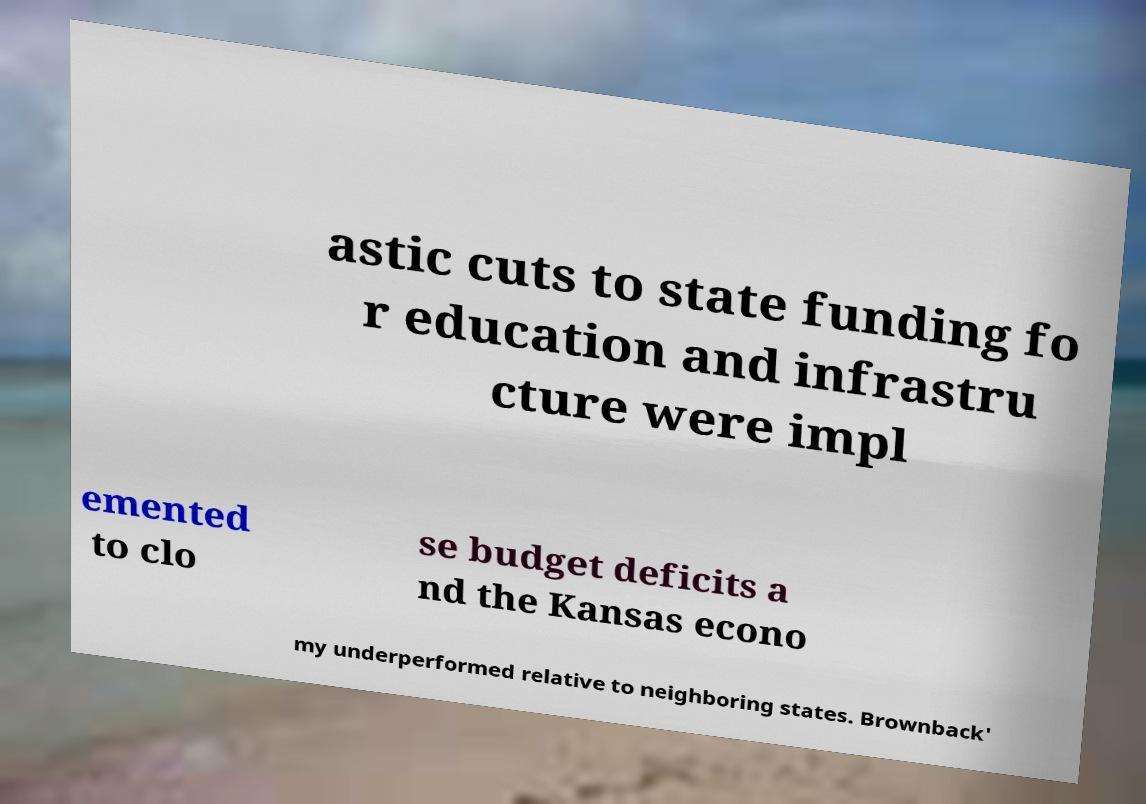Could you extract and type out the text from this image? astic cuts to state funding fo r education and infrastru cture were impl emented to clo se budget deficits a nd the Kansas econo my underperformed relative to neighboring states. Brownback' 